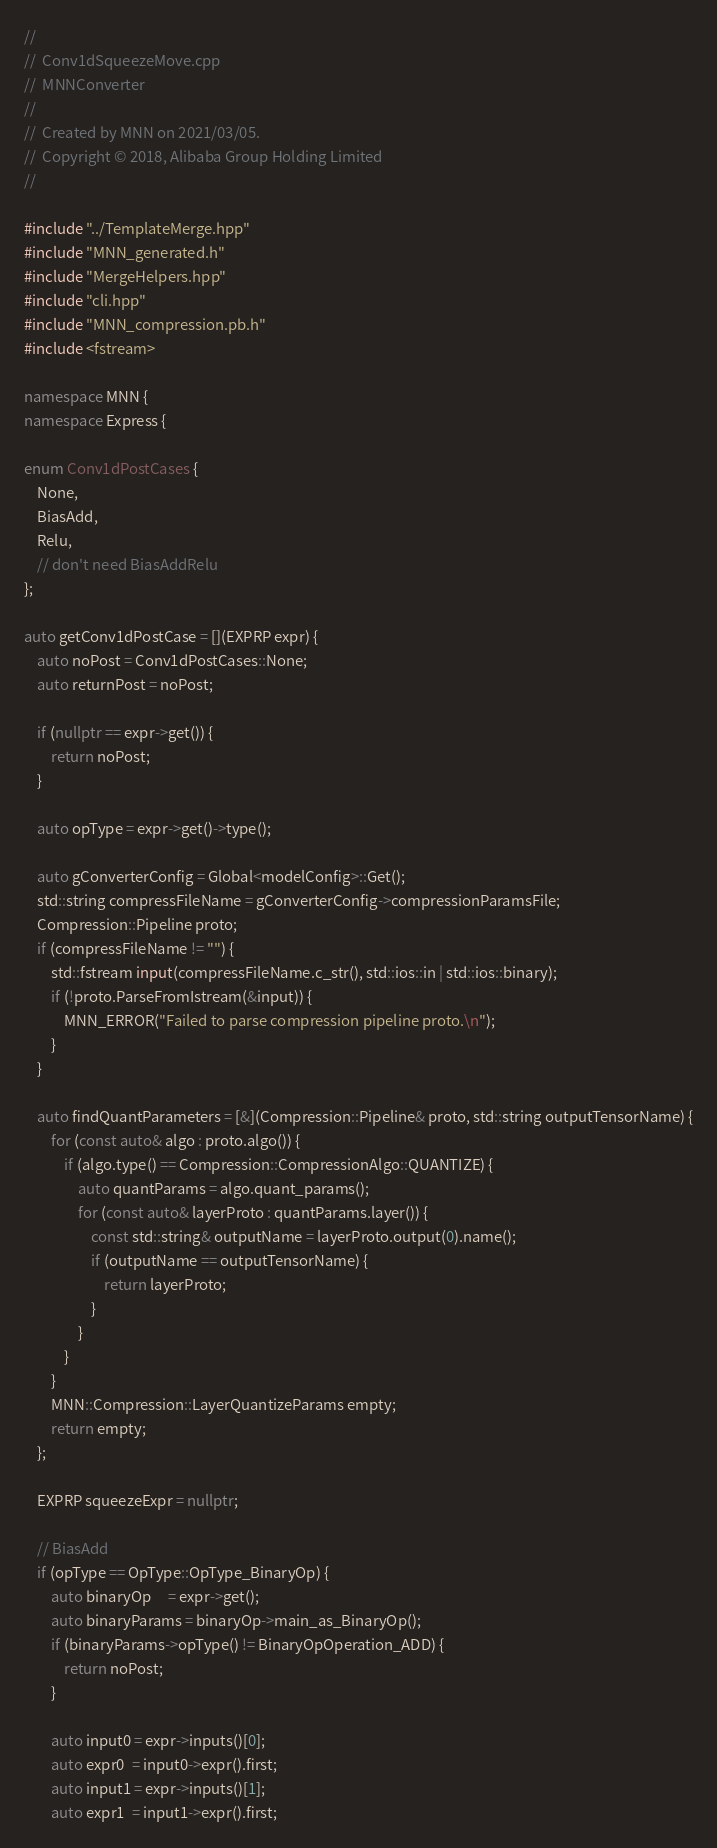<code> <loc_0><loc_0><loc_500><loc_500><_C++_>//
//  Conv1dSqueezeMove.cpp
//  MNNConverter
//
//  Created by MNN on 2021/03/05.
//  Copyright © 2018, Alibaba Group Holding Limited
//

#include "../TemplateMerge.hpp"
#include "MNN_generated.h"
#include "MergeHelpers.hpp"
#include "cli.hpp"
#include "MNN_compression.pb.h"
#include <fstream>

namespace MNN {
namespace Express {

enum Conv1dPostCases {
    None,
    BiasAdd,
    Relu,
    // don't need BiasAddRelu
};

auto getConv1dPostCase = [](EXPRP expr) {
    auto noPost = Conv1dPostCases::None;
    auto returnPost = noPost;

    if (nullptr == expr->get()) {
        return noPost;
    }

    auto opType = expr->get()->type();

    auto gConverterConfig = Global<modelConfig>::Get();
    std::string compressFileName = gConverterConfig->compressionParamsFile;
    Compression::Pipeline proto;
    if (compressFileName != "") {
        std::fstream input(compressFileName.c_str(), std::ios::in | std::ios::binary);
        if (!proto.ParseFromIstream(&input)) {
            MNN_ERROR("Failed to parse compression pipeline proto.\n");
        }
    }

    auto findQuantParameters = [&](Compression::Pipeline& proto, std::string outputTensorName) {
        for (const auto& algo : proto.algo()) {
            if (algo.type() == Compression::CompressionAlgo::QUANTIZE) {
                auto quantParams = algo.quant_params();
                for (const auto& layerProto : quantParams.layer()) {
                    const std::string& outputName = layerProto.output(0).name();
                    if (outputName == outputTensorName) {
                        return layerProto;
                    }
                }
            }
        }
        MNN::Compression::LayerQuantizeParams empty;
        return empty;
    };

    EXPRP squeezeExpr = nullptr;

    // BiasAdd
    if (opType == OpType::OpType_BinaryOp) {
        auto binaryOp     = expr->get();
        auto binaryParams = binaryOp->main_as_BinaryOp();
        if (binaryParams->opType() != BinaryOpOperation_ADD) {
            return noPost;
        }

        auto input0 = expr->inputs()[0];
        auto expr0  = input0->expr().first;
        auto input1 = expr->inputs()[1];
        auto expr1  = input1->expr().first;
</code> 